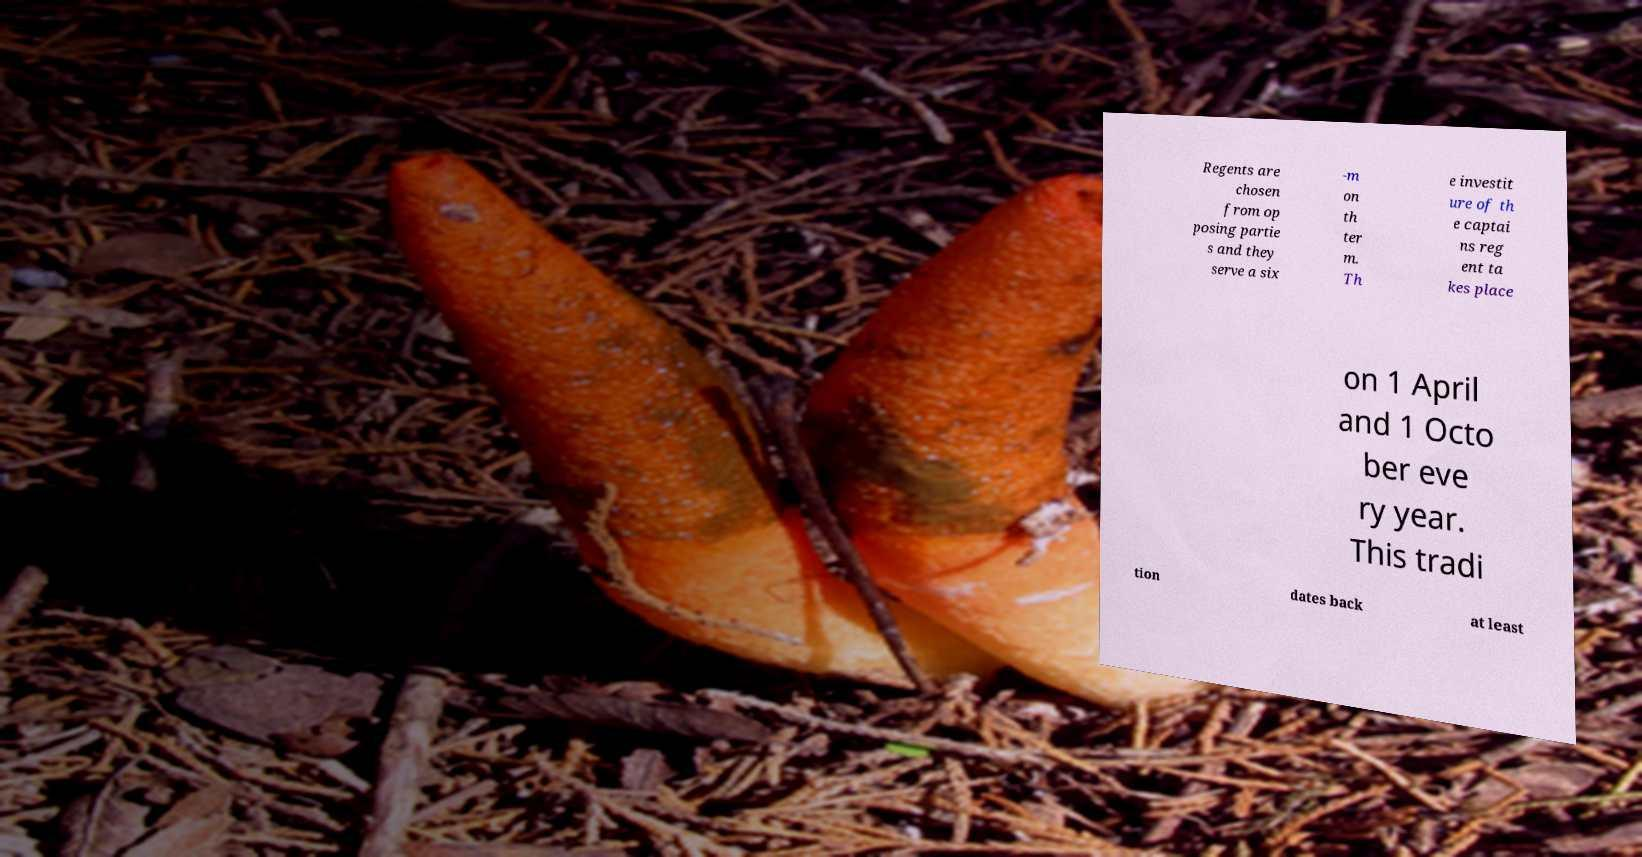Can you read and provide the text displayed in the image?This photo seems to have some interesting text. Can you extract and type it out for me? Regents are chosen from op posing partie s and they serve a six -m on th ter m. Th e investit ure of th e captai ns reg ent ta kes place on 1 April and 1 Octo ber eve ry year. This tradi tion dates back at least 